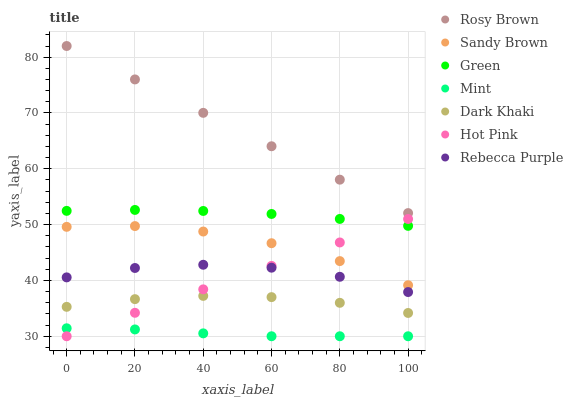Does Mint have the minimum area under the curve?
Answer yes or no. Yes. Does Rosy Brown have the maximum area under the curve?
Answer yes or no. Yes. Does Rosy Brown have the minimum area under the curve?
Answer yes or no. No. Does Mint have the maximum area under the curve?
Answer yes or no. No. Is Hot Pink the smoothest?
Answer yes or no. Yes. Is Sandy Brown the roughest?
Answer yes or no. Yes. Is Mint the smoothest?
Answer yes or no. No. Is Mint the roughest?
Answer yes or no. No. Does Hot Pink have the lowest value?
Answer yes or no. Yes. Does Rosy Brown have the lowest value?
Answer yes or no. No. Does Rosy Brown have the highest value?
Answer yes or no. Yes. Does Mint have the highest value?
Answer yes or no. No. Is Sandy Brown less than Green?
Answer yes or no. Yes. Is Green greater than Sandy Brown?
Answer yes or no. Yes. Does Hot Pink intersect Mint?
Answer yes or no. Yes. Is Hot Pink less than Mint?
Answer yes or no. No. Is Hot Pink greater than Mint?
Answer yes or no. No. Does Sandy Brown intersect Green?
Answer yes or no. No. 